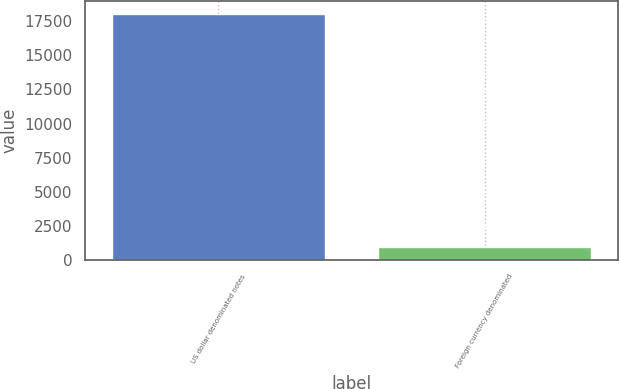Convert chart. <chart><loc_0><loc_0><loc_500><loc_500><bar_chart><fcel>US dollar denominated notes<fcel>Foreign currency denominated<nl><fcel>18045<fcel>955<nl></chart> 